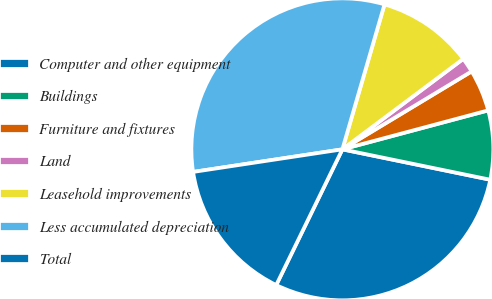Convert chart to OTSL. <chart><loc_0><loc_0><loc_500><loc_500><pie_chart><fcel>Computer and other equipment<fcel>Buildings<fcel>Furniture and fixtures<fcel>Land<fcel>Leasehold improvements<fcel>Less accumulated depreciation<fcel>Total<nl><fcel>28.99%<fcel>7.38%<fcel>4.48%<fcel>1.59%<fcel>10.27%<fcel>31.89%<fcel>15.39%<nl></chart> 